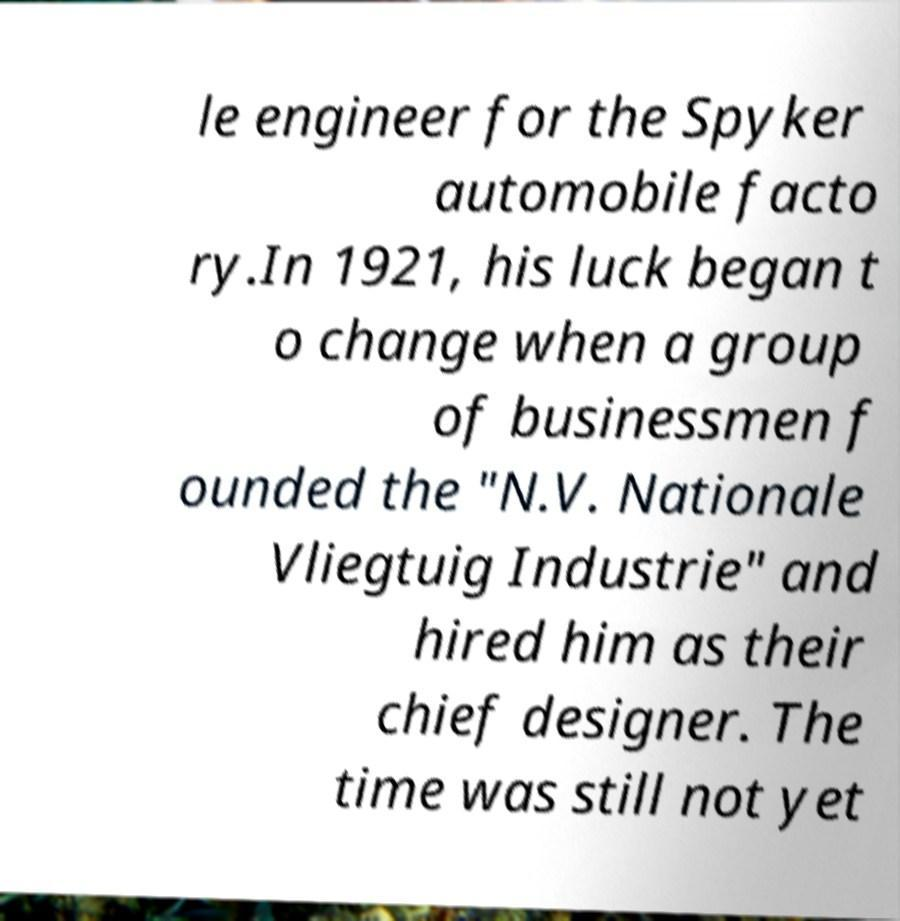Please read and relay the text visible in this image. What does it say? le engineer for the Spyker automobile facto ry.In 1921, his luck began t o change when a group of businessmen f ounded the "N.V. Nationale Vliegtuig Industrie" and hired him as their chief designer. The time was still not yet 